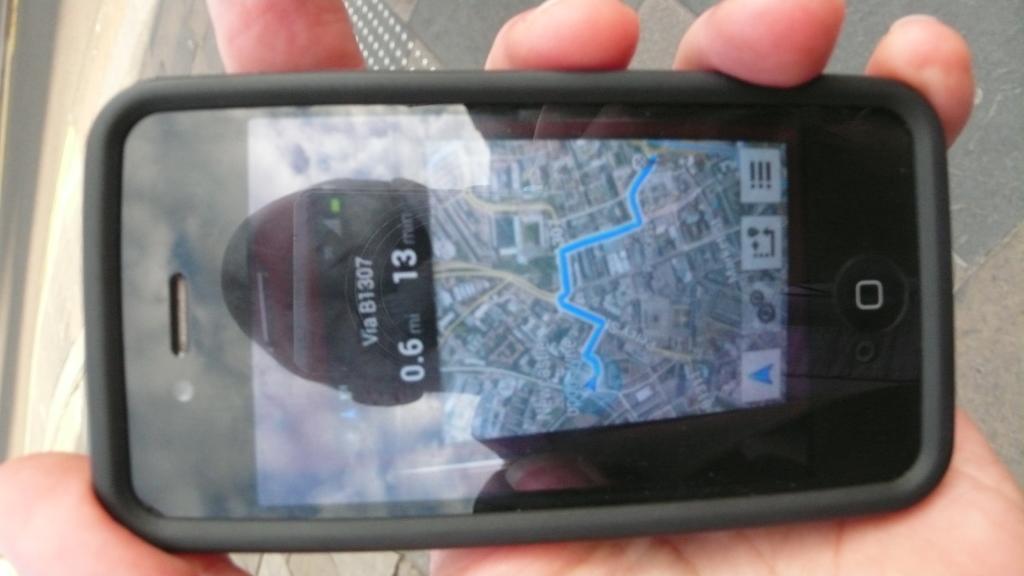Can you describe this image briefly? In this picture we can see a person hand is holding a mobile and in the background we can see the road. 